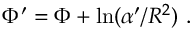<formula> <loc_0><loc_0><loc_500><loc_500>\Phi ^ { \prime } = \Phi + \ln ( \alpha ^ { \prime } / R ^ { 2 } ) \ .</formula> 